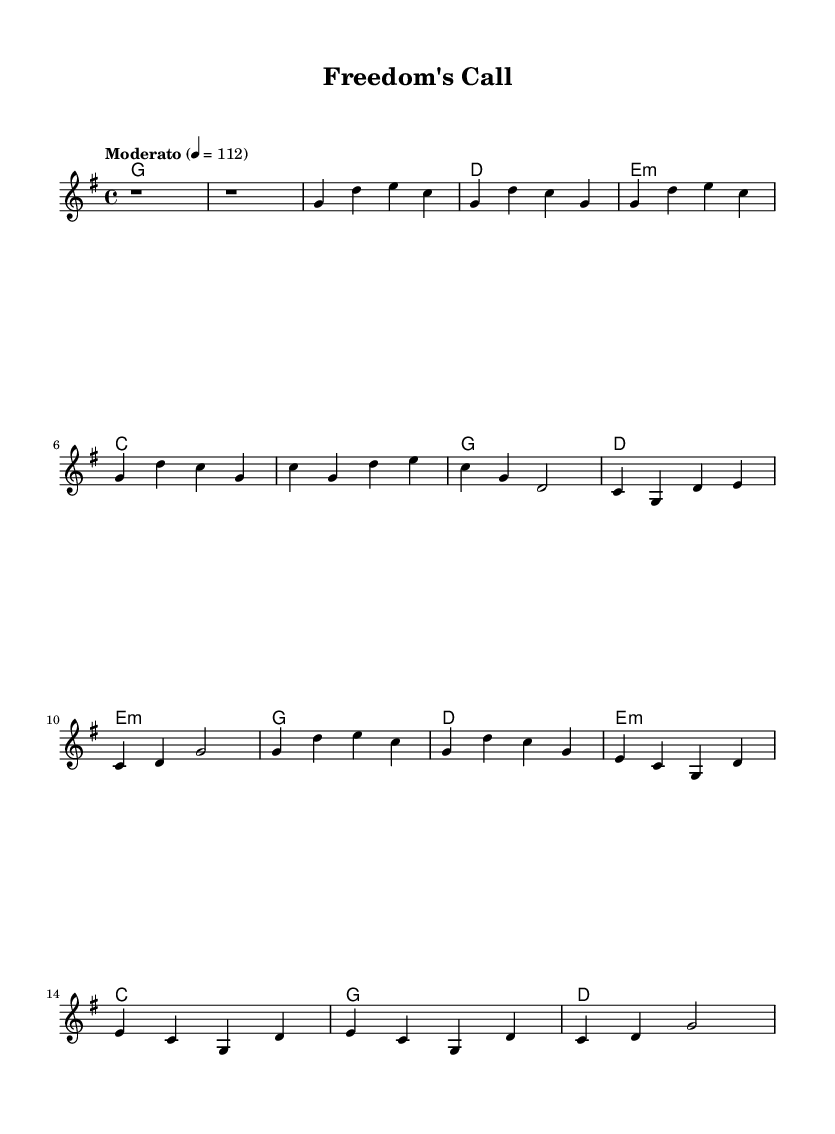What is the key signature of this music? The key signature is G major, which has one sharp (F#). This can be identified in the music sheet where the key signature is indicated at the beginning of the staff.
Answer: G major What is the time signature of this music? The time signature is 4/4, which indicates that there are four beats in each measure and the quarter note gets one beat. This can be seen notated at the beginning of the music piece.
Answer: 4/4 What is the tempo marking of the piece? The tempo marking is "Moderato," which indicates a moderate pace of the music. This is located near the beginning of the score, providing guidance on the expected speed.
Answer: Moderato How many verses are in the song? There are two verses in the song. This can be deduced from the structure displayed in the sheet music, where two verses are indicated in the melody sections and their lengths are specified.
Answer: Two What is the dominant chord for the chorus? The dominant chord for the chorus is D major. This can be determined by looking at the harmonies section, where D is listed as the chord played in the chorus section of the music.
Answer: D What happens in the bridge of the song? In the bridge of the song, the chords change to E minor, C, G, and D. This can be observed in the harmonies section, where these specific chords are written, indicating a shift in the song's progression.
Answer: E minor, C, G, D What musical genre does this piece belong to? The piece belongs to the Country Rock genre. This classification is based on the style of the melody and chords used, which often incorporates elements typical of country music combined with rock influences, as reflected in the themes and structure of the song.
Answer: Country Rock 